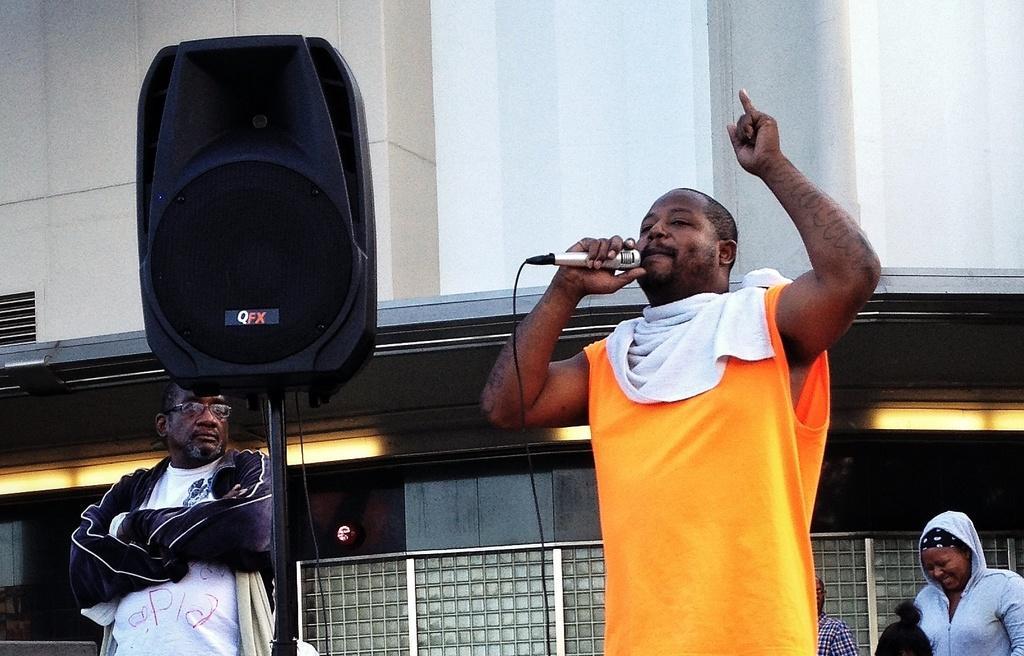Describe this image in one or two sentences. This picture is of the outside. On the right there is a Man standing and holding a microphone in his hand and seems to be singing. On the bottom right there is a Woman standing and smiling. On the left there is a speaker attached with a stand and next to that there is a man folding his hands and standing. In the background there is a Building. 